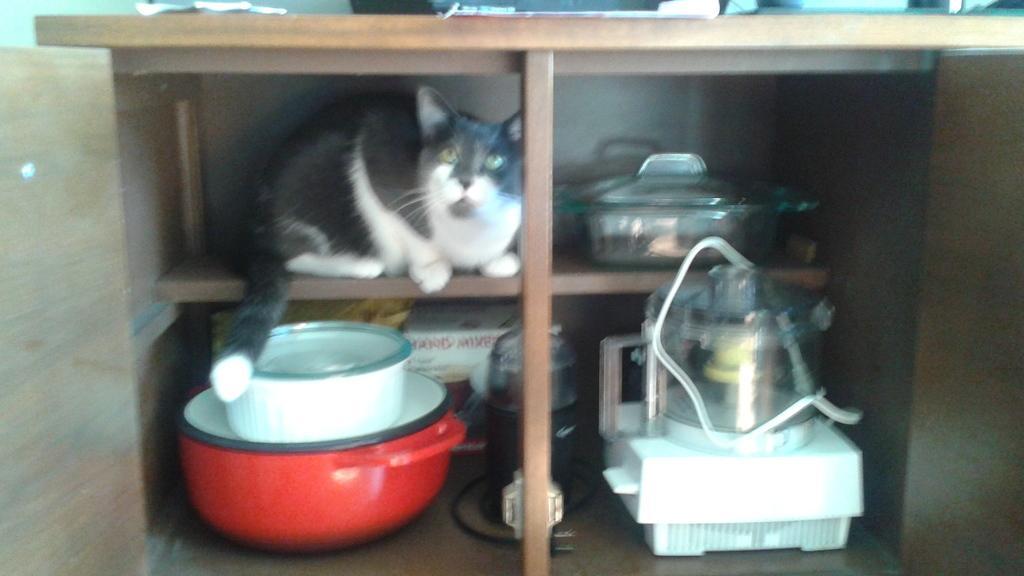Could you give a brief overview of what you see in this image? In this image I can see the brown color rack. Inside the rack I can see the cat which is in white and black color. And I can see some utensils, pan and mixer grinder in it. 